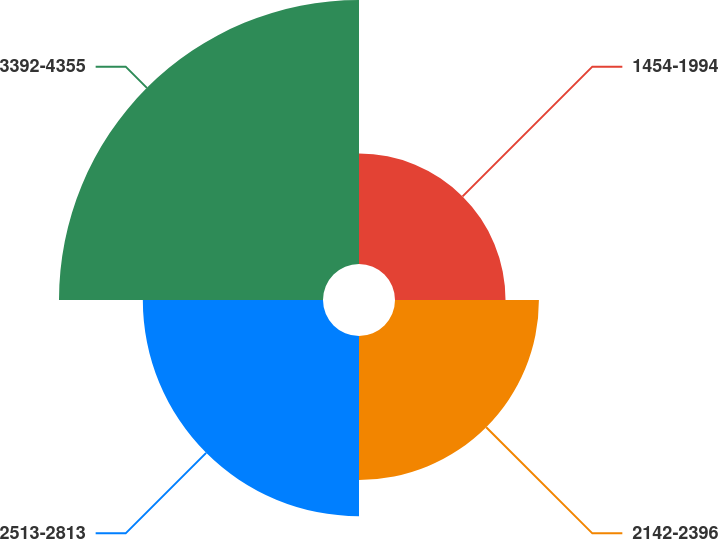Convert chart to OTSL. <chart><loc_0><loc_0><loc_500><loc_500><pie_chart><fcel>1454-1994<fcel>2142-2396<fcel>2513-2813<fcel>3392-4355<nl><fcel>15.82%<fcel>20.6%<fcel>25.79%<fcel>37.79%<nl></chart> 